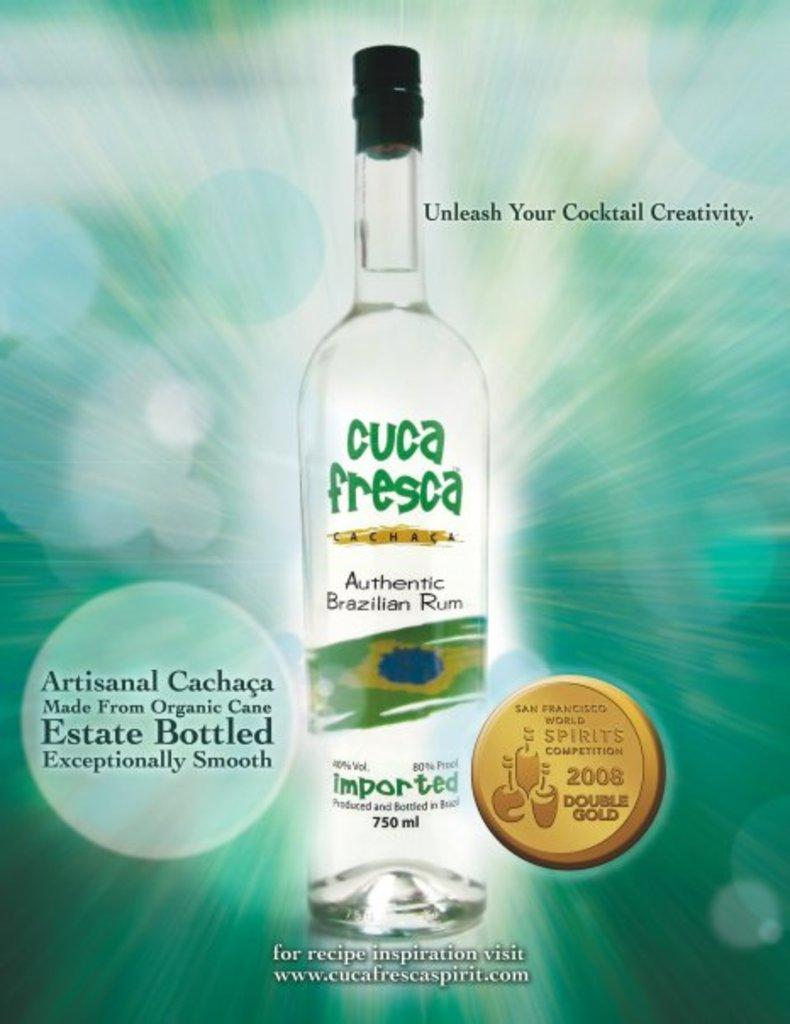<image>
Share a concise interpretation of the image provided. An advertisement for Cuca Fresca Run with a blue background. 